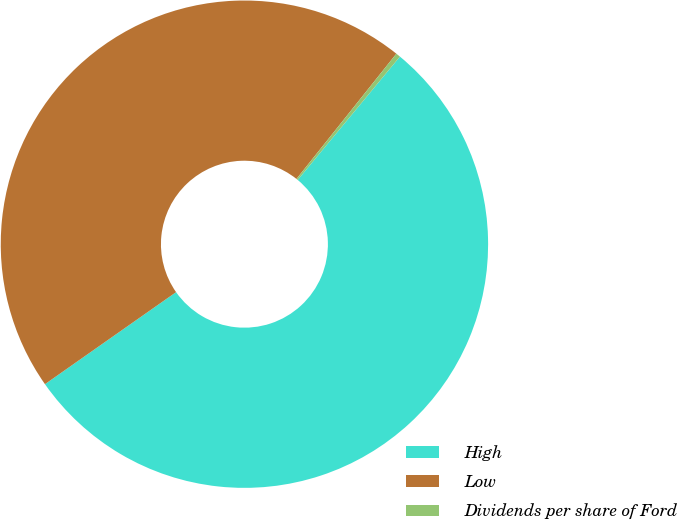Convert chart to OTSL. <chart><loc_0><loc_0><loc_500><loc_500><pie_chart><fcel>High<fcel>Low<fcel>Dividends per share of Ford<nl><fcel>54.24%<fcel>45.45%<fcel>0.3%<nl></chart> 